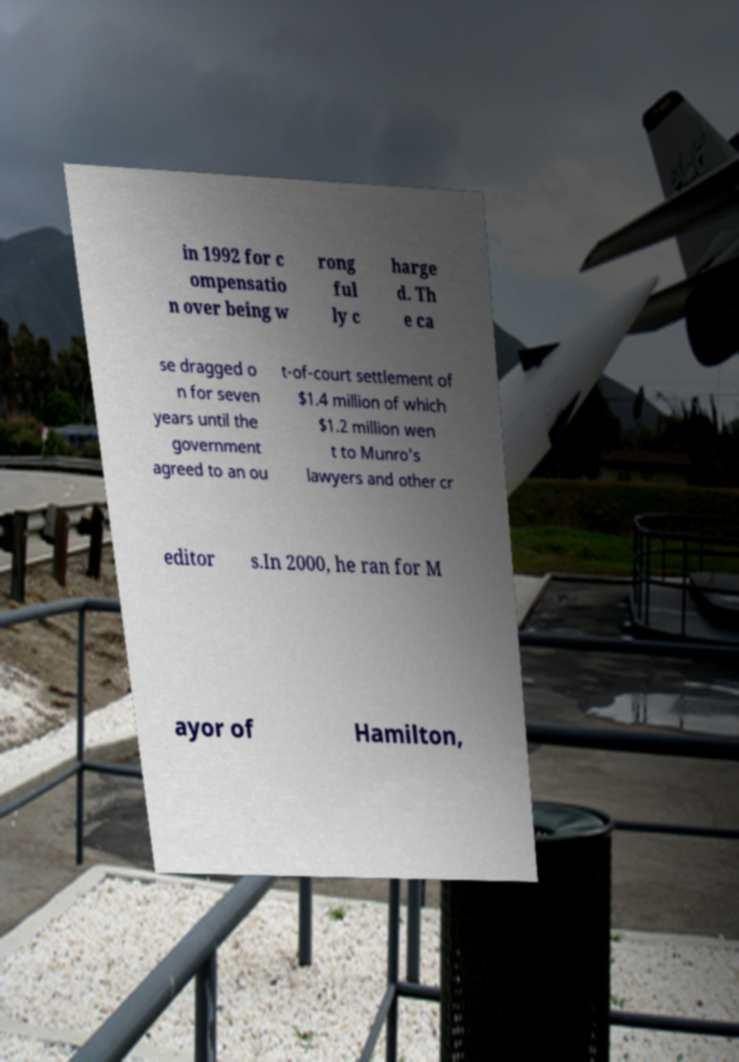Please read and relay the text visible in this image. What does it say? in 1992 for c ompensatio n over being w rong ful ly c harge d. Th e ca se dragged o n for seven years until the government agreed to an ou t-of-court settlement of $1.4 million of which $1.2 million wen t to Munro's lawyers and other cr editor s.In 2000, he ran for M ayor of Hamilton, 